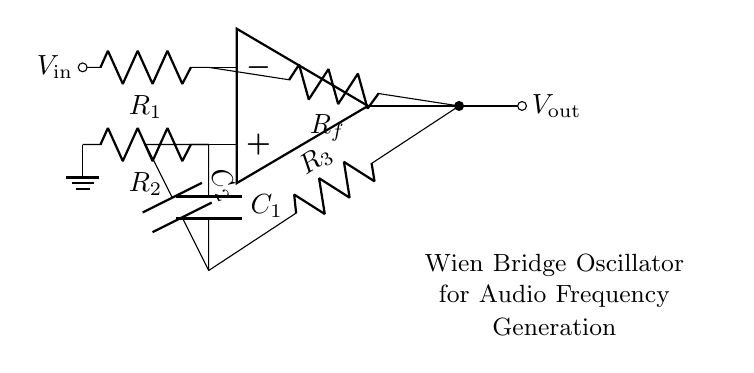What type of components are in the circuit? The circuit consists of resistors, capacitors, and an operational amplifier, which are the basic components of the Wien bridge oscillator used for audio frequency generation.
Answer: resistors, capacitors, operational amplifier What is the purpose of the feedback resistor Rf? The feedback resistor Rf controls the gain of the operational amplifier in this oscillator circuit, which is essential for stabilizing oscillations.
Answer: control gain How many capacitors are present in the circuit? There are two capacitors (C1 and C2) in the Wien bridge oscillator, which are crucial for determining the frequency of oscillation.
Answer: two What effect do C1 and C2 have on oscillation frequency? The values of capacitors C1 and C2 directly influence the oscillation frequency through the formula, where frequency is inversely proportional to capacitance.
Answer: determine frequency Why is one of the resistors grounded in the circuit? Grounding one of the resistors establishes a reference point for the circuit, which enables accurate voltage levels and stable operation of the oscillator.
Answer: establishes reference What would happen if Rf were too high? If Rf were too high, the gain of the amplifier would exceed the necessary level, potentially leading to distortion or unstable oscillation.
Answer: instability 